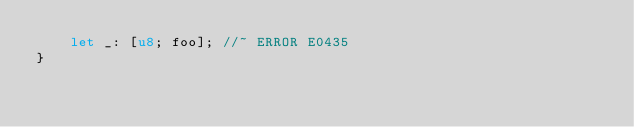Convert code to text. <code><loc_0><loc_0><loc_500><loc_500><_Rust_>    let _: [u8; foo]; //~ ERROR E0435
}
</code> 